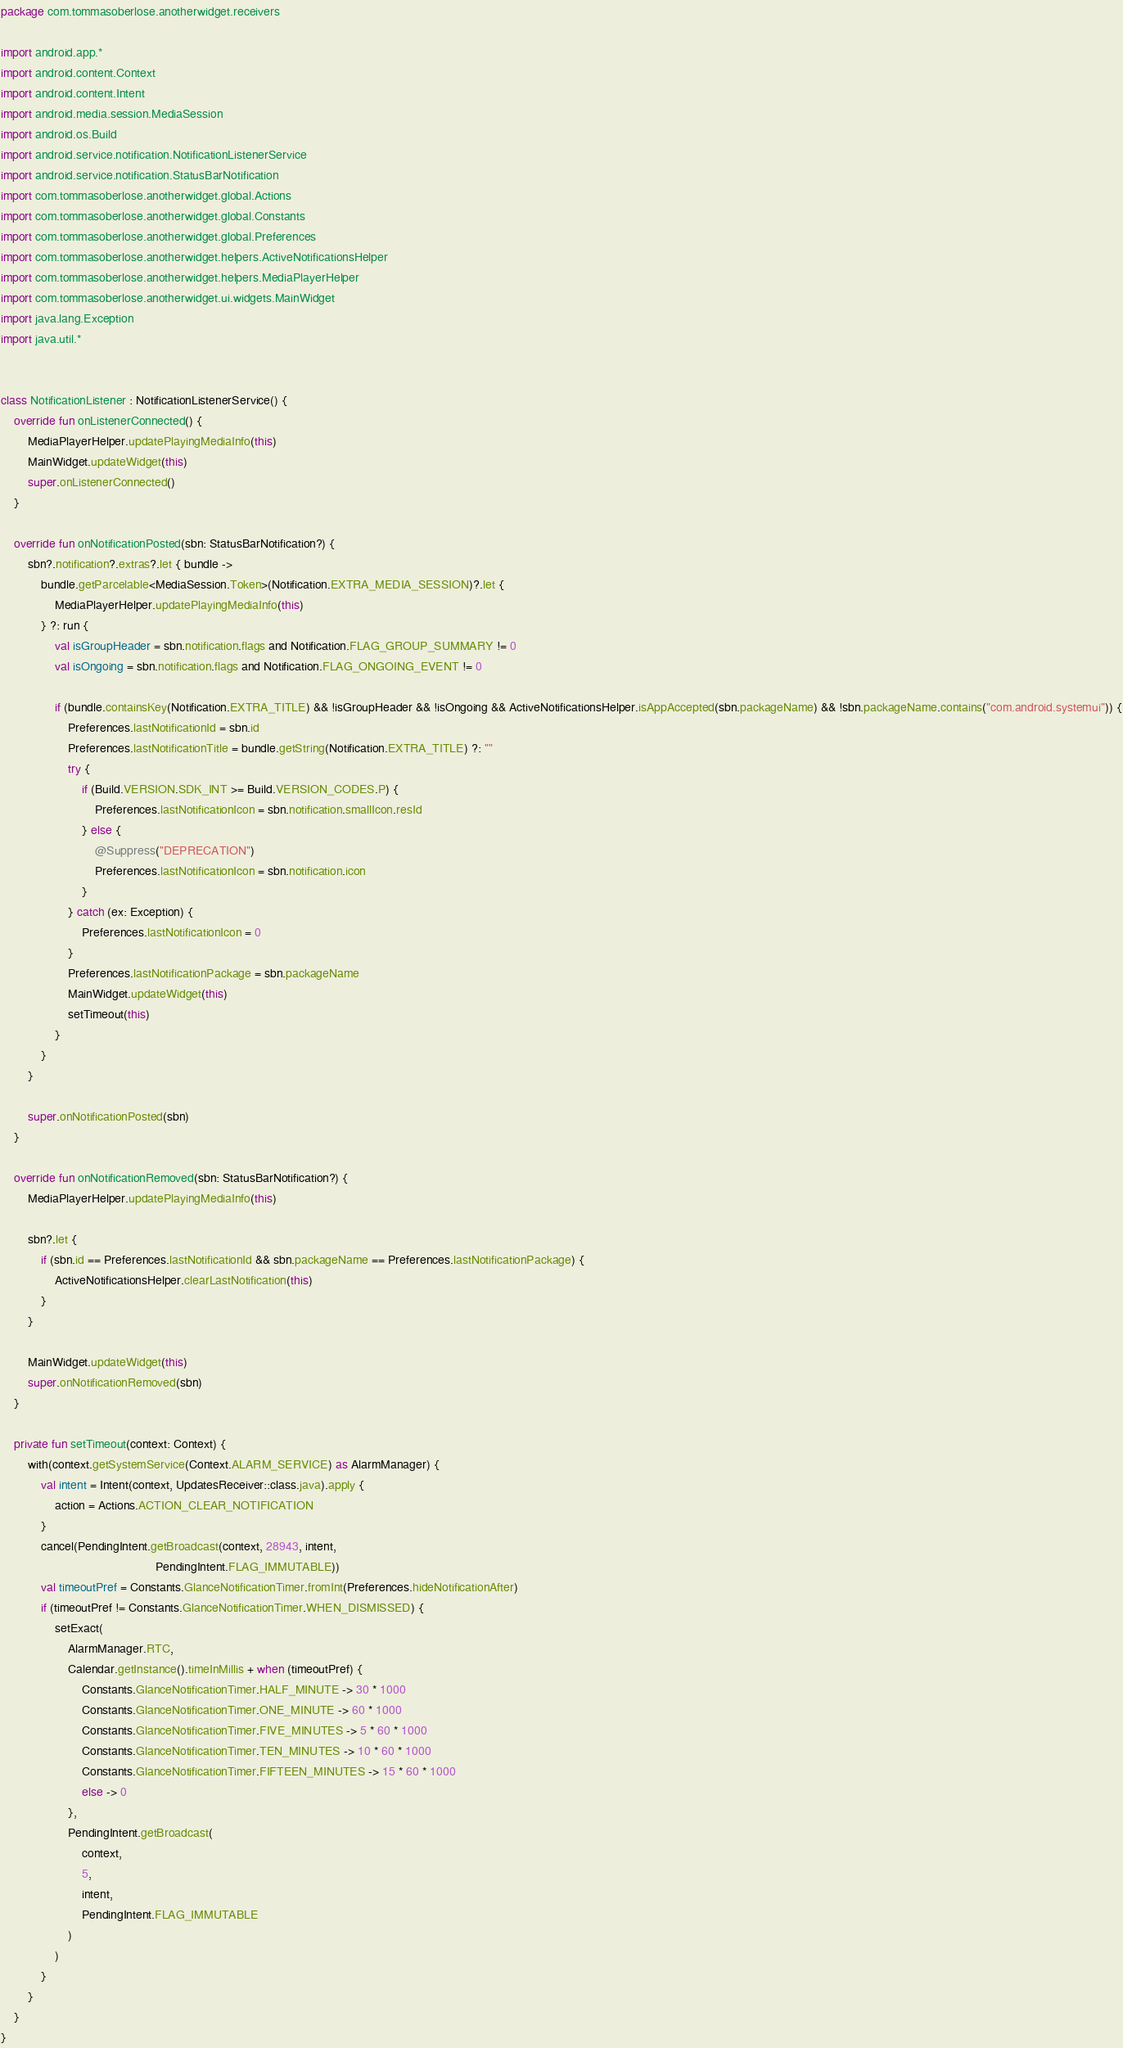Convert code to text. <code><loc_0><loc_0><loc_500><loc_500><_Kotlin_>package com.tommasoberlose.anotherwidget.receivers

import android.app.*
import android.content.Context
import android.content.Intent
import android.media.session.MediaSession
import android.os.Build
import android.service.notification.NotificationListenerService
import android.service.notification.StatusBarNotification
import com.tommasoberlose.anotherwidget.global.Actions
import com.tommasoberlose.anotherwidget.global.Constants
import com.tommasoberlose.anotherwidget.global.Preferences
import com.tommasoberlose.anotherwidget.helpers.ActiveNotificationsHelper
import com.tommasoberlose.anotherwidget.helpers.MediaPlayerHelper
import com.tommasoberlose.anotherwidget.ui.widgets.MainWidget
import java.lang.Exception
import java.util.*


class NotificationListener : NotificationListenerService() {
    override fun onListenerConnected() {
        MediaPlayerHelper.updatePlayingMediaInfo(this)
        MainWidget.updateWidget(this)
        super.onListenerConnected()
    }

    override fun onNotificationPosted(sbn: StatusBarNotification?) {
        sbn?.notification?.extras?.let { bundle ->
            bundle.getParcelable<MediaSession.Token>(Notification.EXTRA_MEDIA_SESSION)?.let {
                MediaPlayerHelper.updatePlayingMediaInfo(this)
            } ?: run {
                val isGroupHeader = sbn.notification.flags and Notification.FLAG_GROUP_SUMMARY != 0
                val isOngoing = sbn.notification.flags and Notification.FLAG_ONGOING_EVENT != 0

                if (bundle.containsKey(Notification.EXTRA_TITLE) && !isGroupHeader && !isOngoing && ActiveNotificationsHelper.isAppAccepted(sbn.packageName) && !sbn.packageName.contains("com.android.systemui")) {
                    Preferences.lastNotificationId = sbn.id
                    Preferences.lastNotificationTitle = bundle.getString(Notification.EXTRA_TITLE) ?: ""
                    try {
                        if (Build.VERSION.SDK_INT >= Build.VERSION_CODES.P) {
                            Preferences.lastNotificationIcon = sbn.notification.smallIcon.resId
                        } else {
                            @Suppress("DEPRECATION")
                            Preferences.lastNotificationIcon = sbn.notification.icon
                        }
                    } catch (ex: Exception) {
                        Preferences.lastNotificationIcon = 0
                    }
                    Preferences.lastNotificationPackage = sbn.packageName
                    MainWidget.updateWidget(this)
                    setTimeout(this)
                }
            }
        }

        super.onNotificationPosted(sbn)
    }

    override fun onNotificationRemoved(sbn: StatusBarNotification?) {
        MediaPlayerHelper.updatePlayingMediaInfo(this)

        sbn?.let {
            if (sbn.id == Preferences.lastNotificationId && sbn.packageName == Preferences.lastNotificationPackage) {
                ActiveNotificationsHelper.clearLastNotification(this)
            }
        }

        MainWidget.updateWidget(this)
        super.onNotificationRemoved(sbn)
    }

    private fun setTimeout(context: Context) {
        with(context.getSystemService(Context.ALARM_SERVICE) as AlarmManager) {
            val intent = Intent(context, UpdatesReceiver::class.java).apply {
                action = Actions.ACTION_CLEAR_NOTIFICATION
            }
            cancel(PendingIntent.getBroadcast(context, 28943, intent,
                                              PendingIntent.FLAG_IMMUTABLE))
            val timeoutPref = Constants.GlanceNotificationTimer.fromInt(Preferences.hideNotificationAfter)
            if (timeoutPref != Constants.GlanceNotificationTimer.WHEN_DISMISSED) {
                setExact(
                    AlarmManager.RTC,
                    Calendar.getInstance().timeInMillis + when (timeoutPref) {
                        Constants.GlanceNotificationTimer.HALF_MINUTE -> 30 * 1000
                        Constants.GlanceNotificationTimer.ONE_MINUTE -> 60 * 1000
                        Constants.GlanceNotificationTimer.FIVE_MINUTES -> 5 * 60 * 1000
                        Constants.GlanceNotificationTimer.TEN_MINUTES -> 10 * 60 * 1000
                        Constants.GlanceNotificationTimer.FIFTEEN_MINUTES -> 15 * 60 * 1000
                        else -> 0
                    },
                    PendingIntent.getBroadcast(
                        context,
                        5,
                        intent,
                        PendingIntent.FLAG_IMMUTABLE
                    )
                )
            }
        }
    }
}</code> 